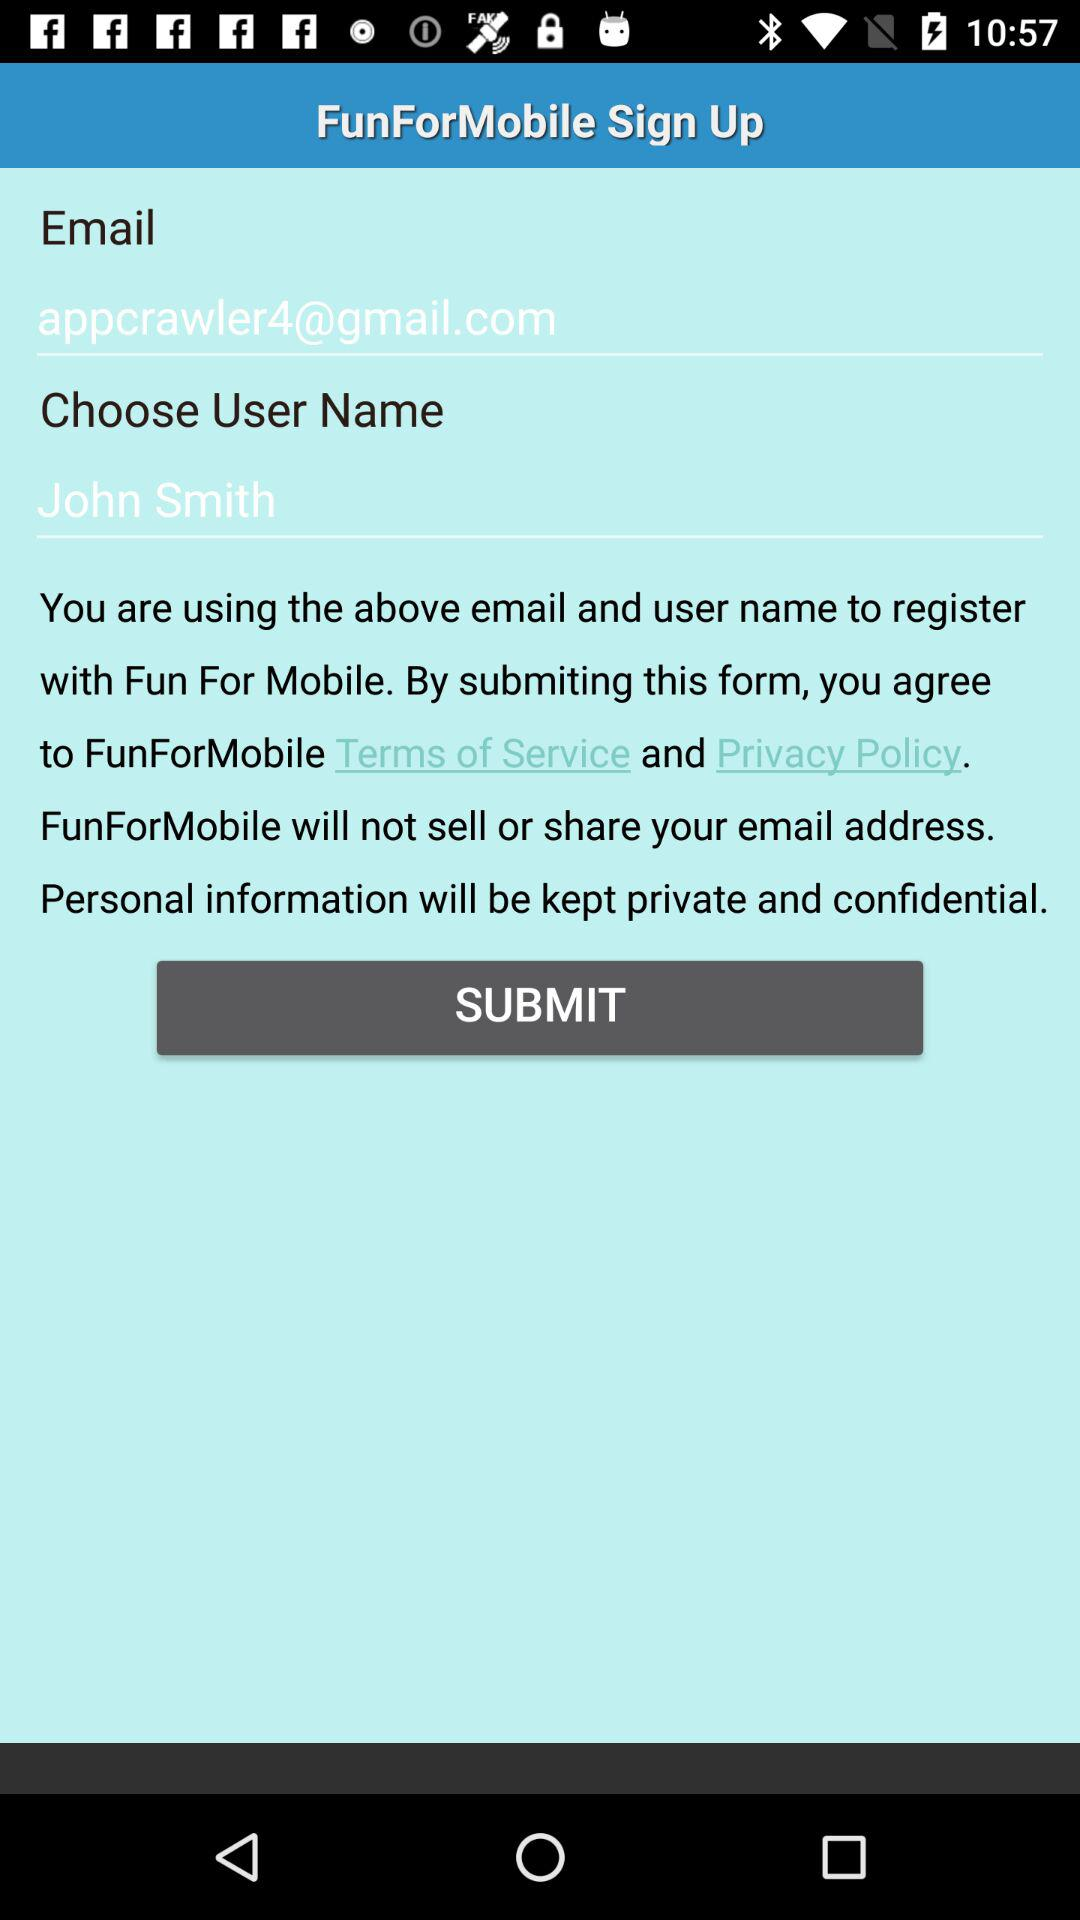How many text fields are there on the screen?
Answer the question using a single word or phrase. 2 